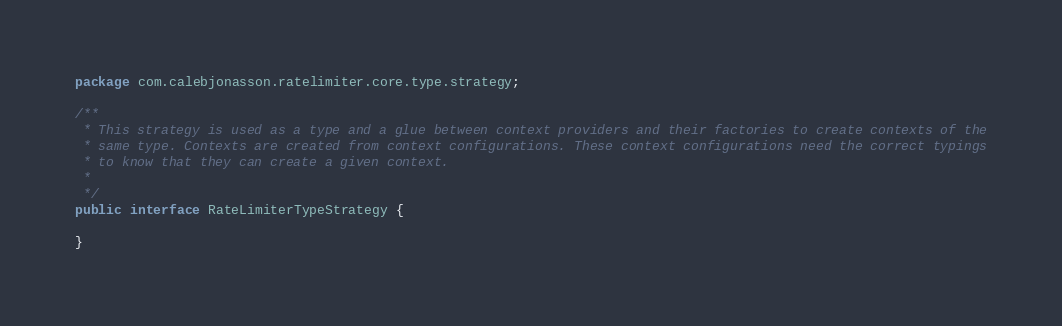<code> <loc_0><loc_0><loc_500><loc_500><_Java_>package com.calebjonasson.ratelimiter.core.type.strategy;

/**
 * This strategy is used as a type and a glue between context providers and their factories to create contexts of the
 * same type. Contexts are created from context configurations. These context configurations need the correct typings
 * to know that they can create a given context.
 *
 */
public interface RateLimiterTypeStrategy {

}</code> 